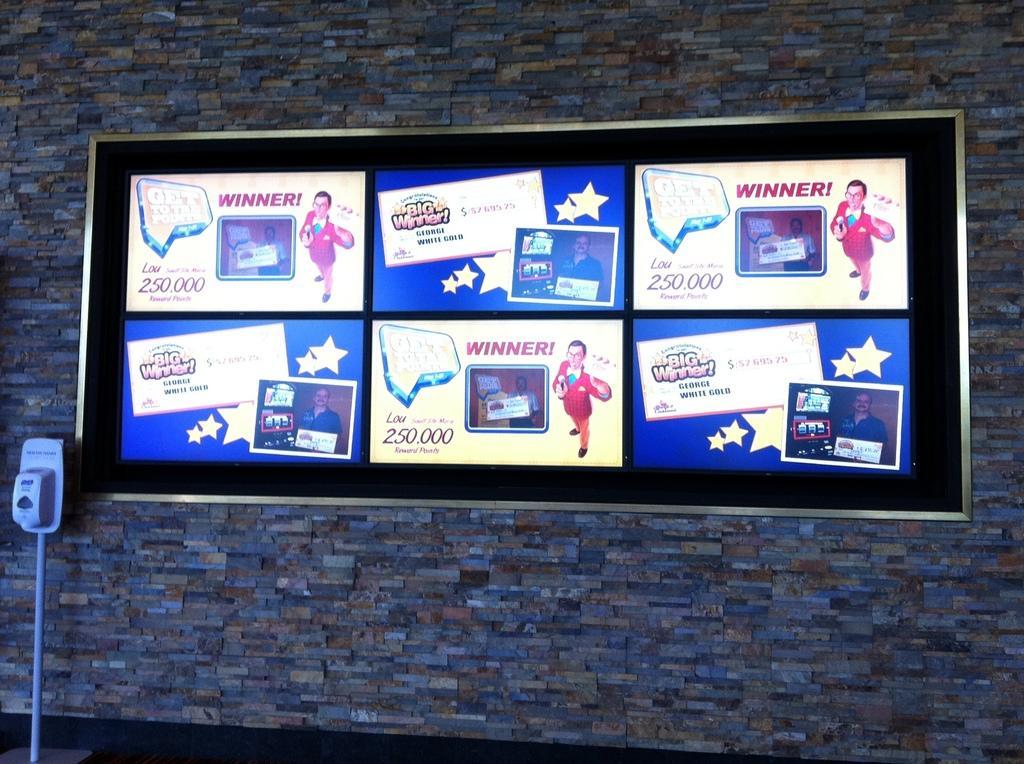In one or two sentences, can you explain what this image depicts? In this image we can see a few lottery winners posters on the notice board on the wall. 